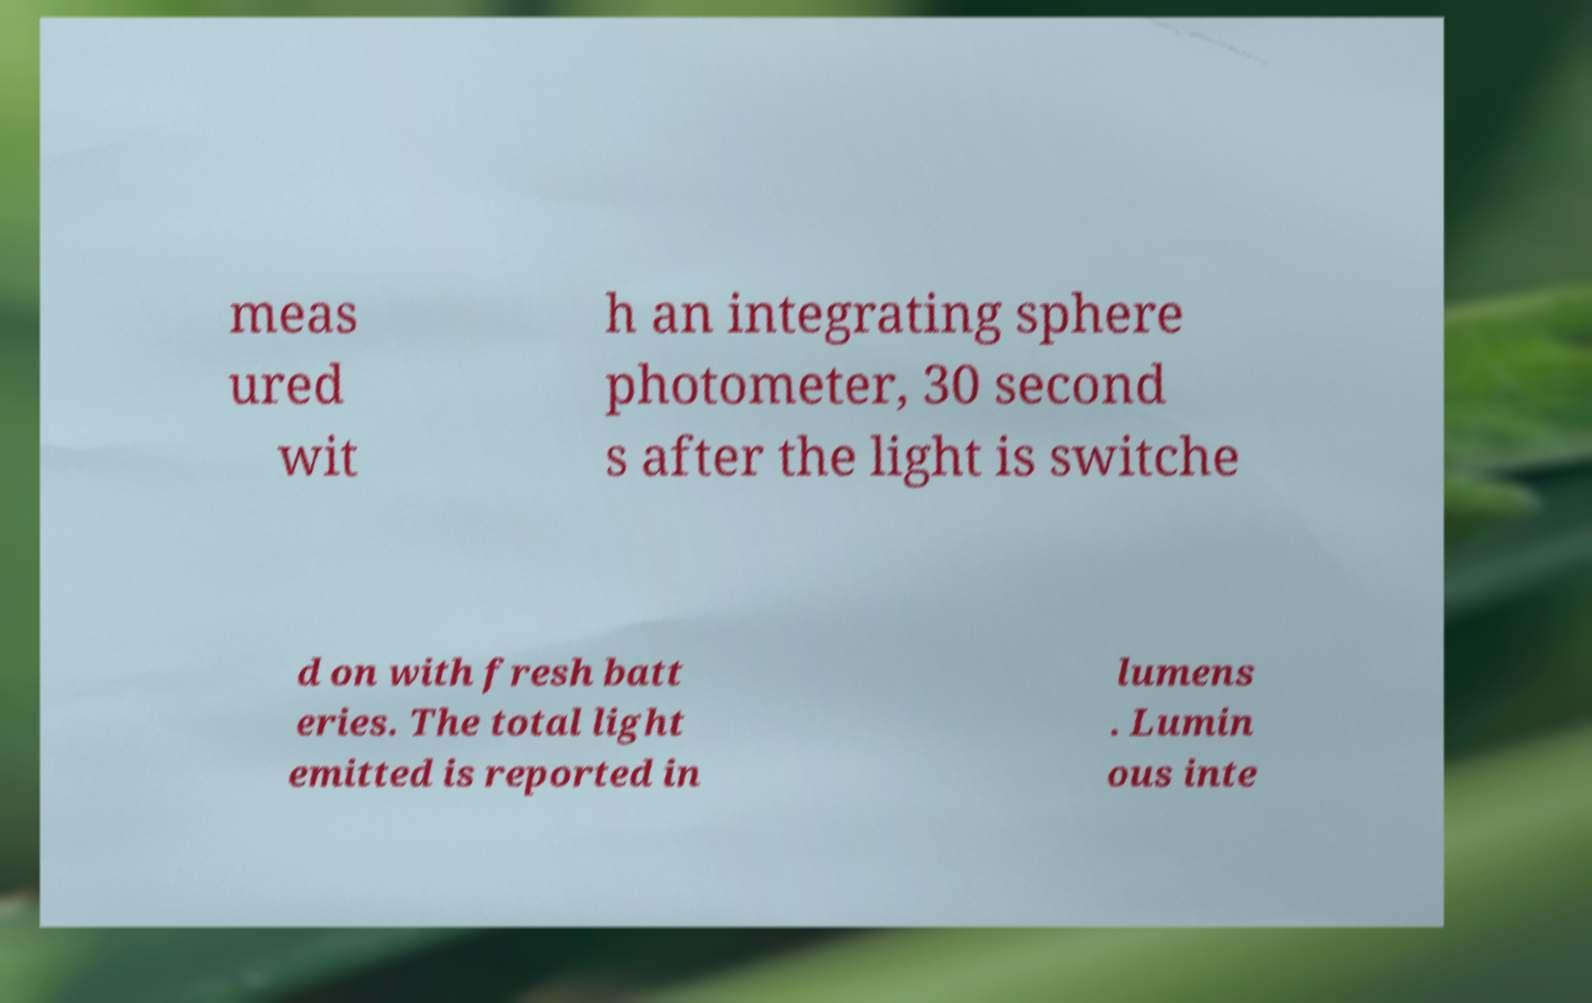Could you assist in decoding the text presented in this image and type it out clearly? meas ured wit h an integrating sphere photometer, 30 second s after the light is switche d on with fresh batt eries. The total light emitted is reported in lumens . Lumin ous inte 